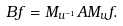<formula> <loc_0><loc_0><loc_500><loc_500>B f = M _ { u ^ { - 1 } } A M _ { u } f .</formula> 